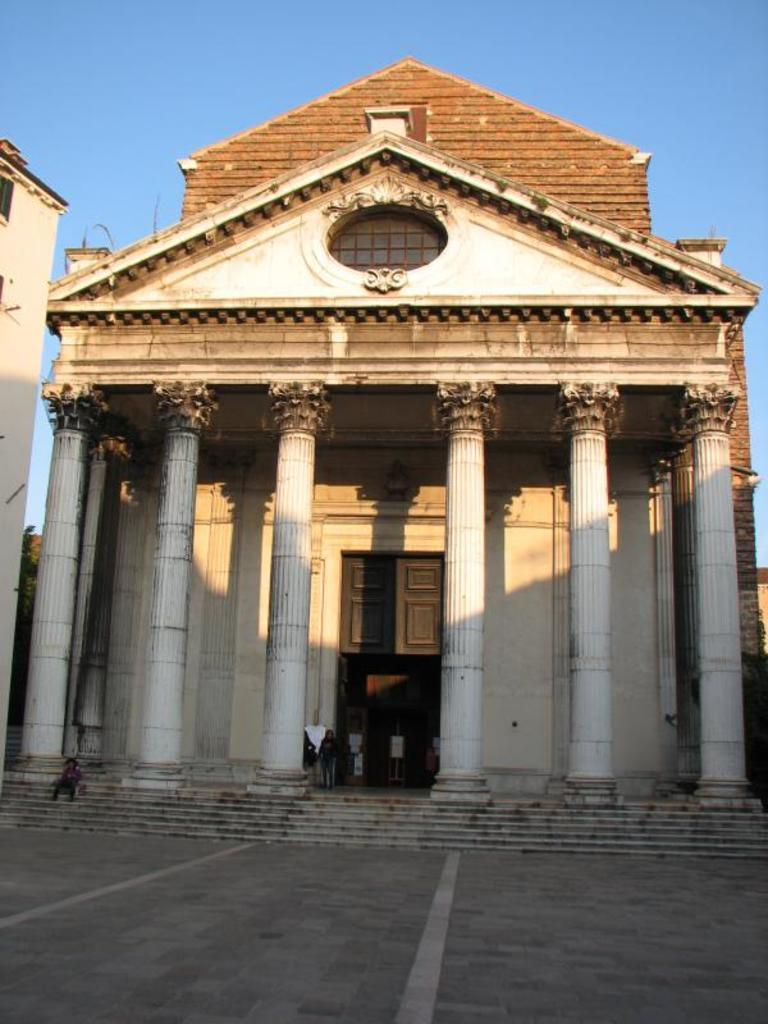What type of structure is present in the image? There is a building in the image. What architectural features can be seen on the building? The building has pillars and a staircase. What is the pathway like in the image? There is a footpath in the image. What can be seen in the sky in the image? The sky is visible in the image. What are the people in the image wearing? The people in the image are wearing clothes. Can you hear the whistle of the plough in the image? A: There is no plough or whistle present in the image; it features a building with people wearing clothes. What type of coat is the person wearing in the image? There is no specific coat mentioned or visible in the image; the people are simply described as wearing clothes. 